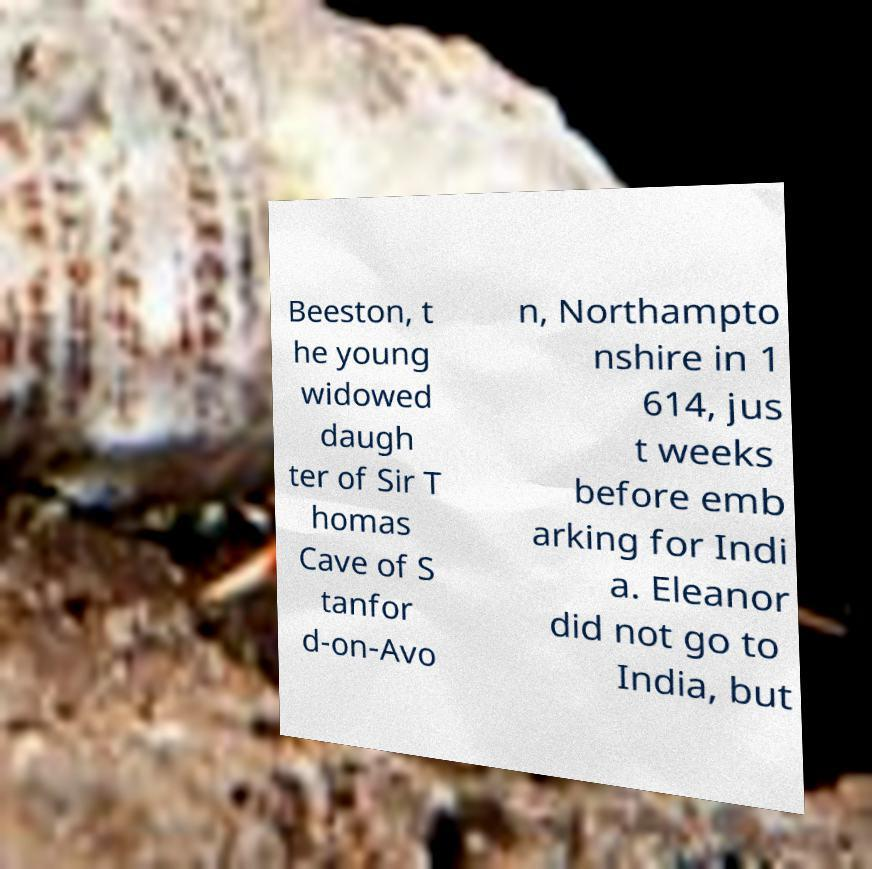Please read and relay the text visible in this image. What does it say? Beeston, t he young widowed daugh ter of Sir T homas Cave of S tanfor d-on-Avo n, Northampto nshire in 1 614, jus t weeks before emb arking for Indi a. Eleanor did not go to India, but 